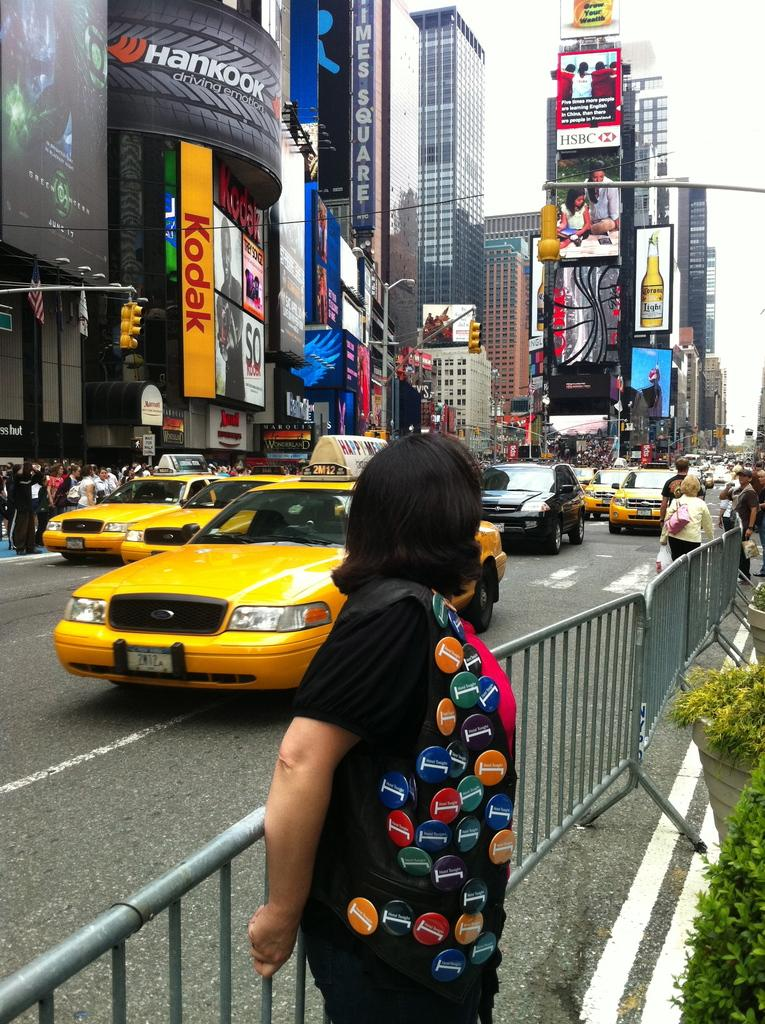<image>
Create a compact narrative representing the image presented. A woman turns away from the camera as she stands on a street with an ad for kodak in the background. 